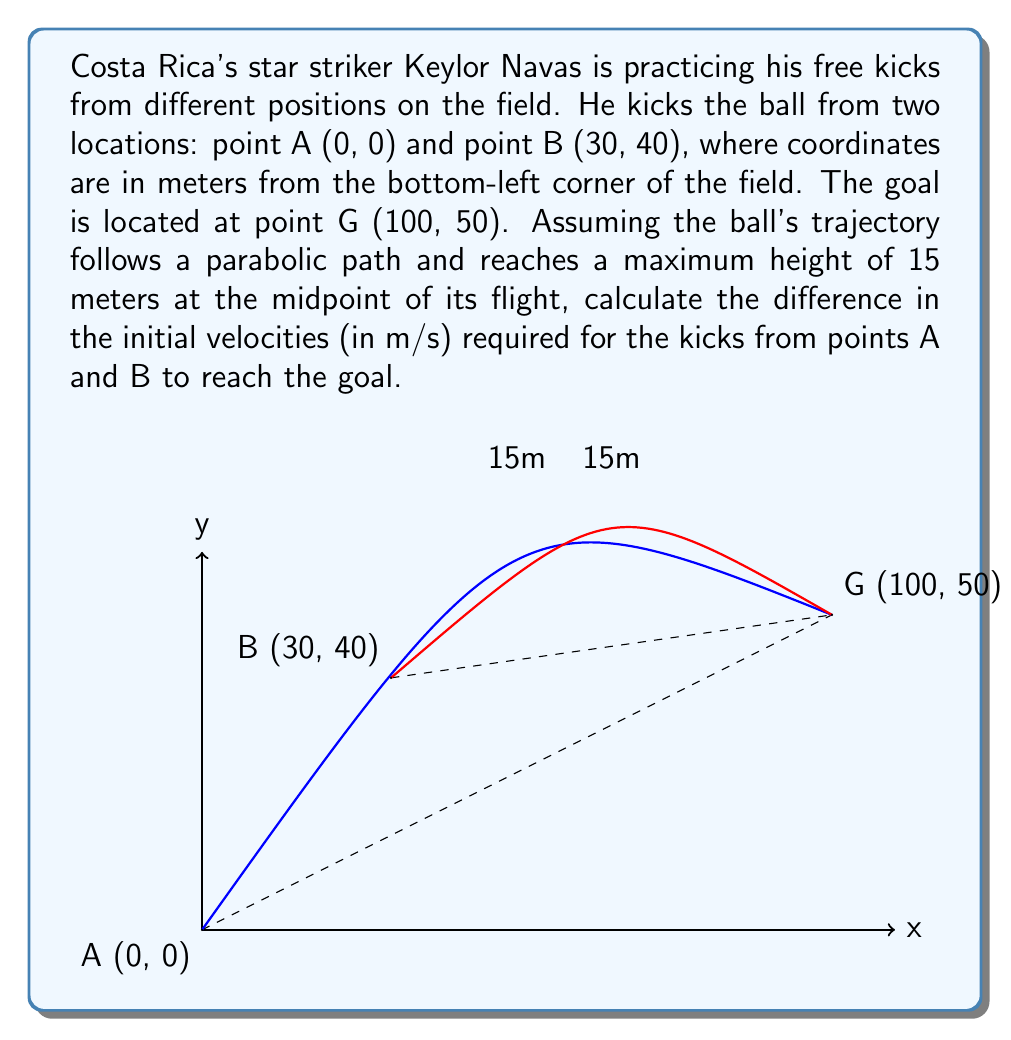What is the answer to this math problem? Let's approach this step-by-step:

1) The general equation for a parabolic trajectory is:
   $$y = -\frac{g}{2v_0^2\cos^2\theta}x^2 + x\tan\theta + h_0$$
   where $g$ is gravitational acceleration (9.8 m/s²), $v_0$ is initial velocity, $\theta$ is launch angle, and $h_0$ is initial height.

2) For both kicks, we know:
   - End point (100, 50)
   - Maximum height of 15m at midpoint

3) For kick A:
   - Start point (0, 0)
   - Midpoint (50, 15)

4) For kick B:
   - Start point (30, 40)
   - Midpoint (65, 55)

5) Using the midpoint and endpoint, we can find the equation of each parabola:
   For A: $y = -0.0064x^2 + 1.6x$
   For B: $y = -0.016x^2 + 2.48x + 22.4$

6) The launch angle $\theta$ can be found from the derivative at x=0:
   For A: $\tan\theta_A = 1.6$, so $\theta_A = 58.0°$
   For B: $\tan\theta_B = 2.48$, so $\theta_B = 68.0°$

7) Substituting these into the general equation and solving for $v_0$:
   For A: $v_0^A = \sqrt{\frac{g}{2(-0.0064)\cos^2 58.0°}} = 28.2$ m/s
   For B: $v_0^B = \sqrt{\frac{g}{2(-0.016)\cos^2 68.0°}} = 22.6$ m/s

8) The difference in initial velocities:
   $28.2 - 22.6 = 5.6$ m/s
Answer: 5.6 m/s 